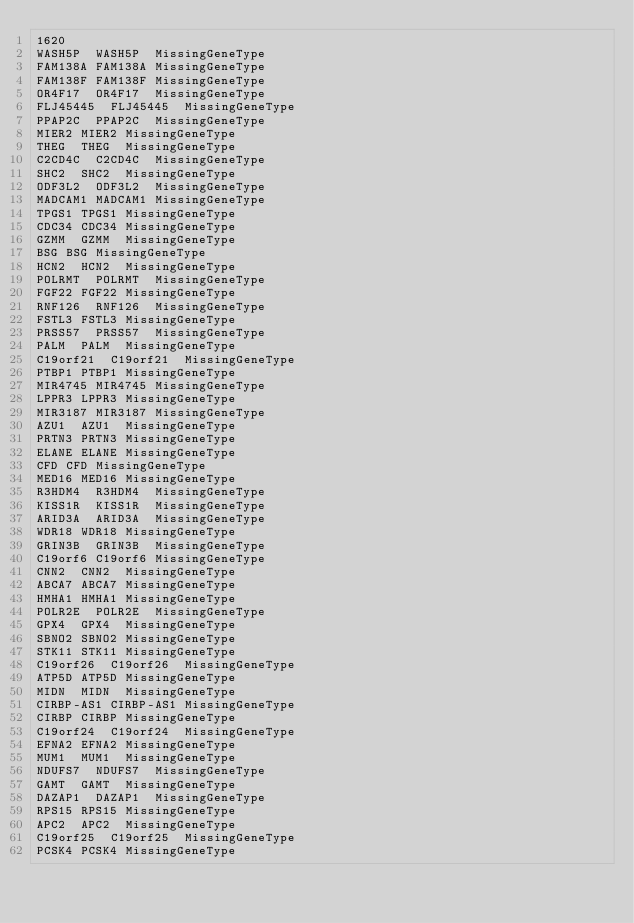<code> <loc_0><loc_0><loc_500><loc_500><_SQL_>1620
WASH5P	WASH5P	MissingGeneType
FAM138A	FAM138A	MissingGeneType
FAM138F	FAM138F	MissingGeneType
OR4F17	OR4F17	MissingGeneType
FLJ45445	FLJ45445	MissingGeneType
PPAP2C	PPAP2C	MissingGeneType
MIER2	MIER2	MissingGeneType
THEG	THEG	MissingGeneType
C2CD4C	C2CD4C	MissingGeneType
SHC2	SHC2	MissingGeneType
ODF3L2	ODF3L2	MissingGeneType
MADCAM1	MADCAM1	MissingGeneType
TPGS1	TPGS1	MissingGeneType
CDC34	CDC34	MissingGeneType
GZMM	GZMM	MissingGeneType
BSG	BSG	MissingGeneType
HCN2	HCN2	MissingGeneType
POLRMT	POLRMT	MissingGeneType
FGF22	FGF22	MissingGeneType
RNF126	RNF126	MissingGeneType
FSTL3	FSTL3	MissingGeneType
PRSS57	PRSS57	MissingGeneType
PALM	PALM	MissingGeneType
C19orf21	C19orf21	MissingGeneType
PTBP1	PTBP1	MissingGeneType
MIR4745	MIR4745	MissingGeneType
LPPR3	LPPR3	MissingGeneType
MIR3187	MIR3187	MissingGeneType
AZU1	AZU1	MissingGeneType
PRTN3	PRTN3	MissingGeneType
ELANE	ELANE	MissingGeneType
CFD	CFD	MissingGeneType
MED16	MED16	MissingGeneType
R3HDM4	R3HDM4	MissingGeneType
KISS1R	KISS1R	MissingGeneType
ARID3A	ARID3A	MissingGeneType
WDR18	WDR18	MissingGeneType
GRIN3B	GRIN3B	MissingGeneType
C19orf6	C19orf6	MissingGeneType
CNN2	CNN2	MissingGeneType
ABCA7	ABCA7	MissingGeneType
HMHA1	HMHA1	MissingGeneType
POLR2E	POLR2E	MissingGeneType
GPX4	GPX4	MissingGeneType
SBNO2	SBNO2	MissingGeneType
STK11	STK11	MissingGeneType
C19orf26	C19orf26	MissingGeneType
ATP5D	ATP5D	MissingGeneType
MIDN	MIDN	MissingGeneType
CIRBP-AS1	CIRBP-AS1	MissingGeneType
CIRBP	CIRBP	MissingGeneType
C19orf24	C19orf24	MissingGeneType
EFNA2	EFNA2	MissingGeneType
MUM1	MUM1	MissingGeneType
NDUFS7	NDUFS7	MissingGeneType
GAMT	GAMT	MissingGeneType
DAZAP1	DAZAP1	MissingGeneType
RPS15	RPS15	MissingGeneType
APC2	APC2	MissingGeneType
C19orf25	C19orf25	MissingGeneType
PCSK4	PCSK4	MissingGeneType</code> 